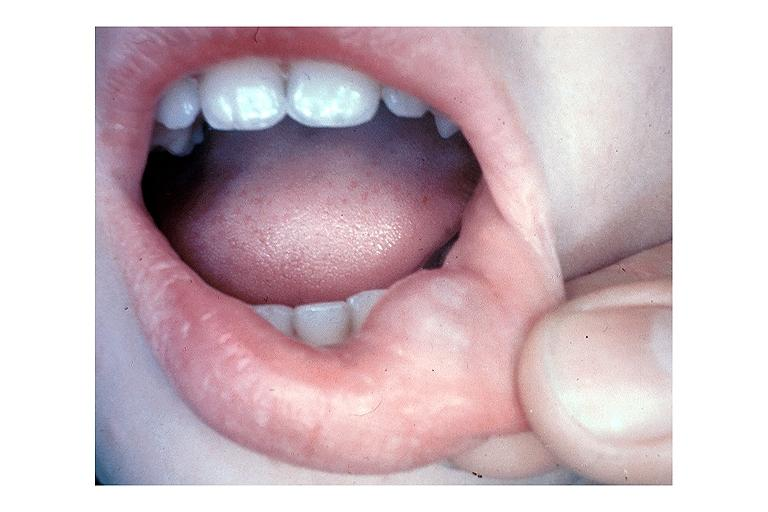does this image show mucocele?
Answer the question using a single word or phrase. Yes 